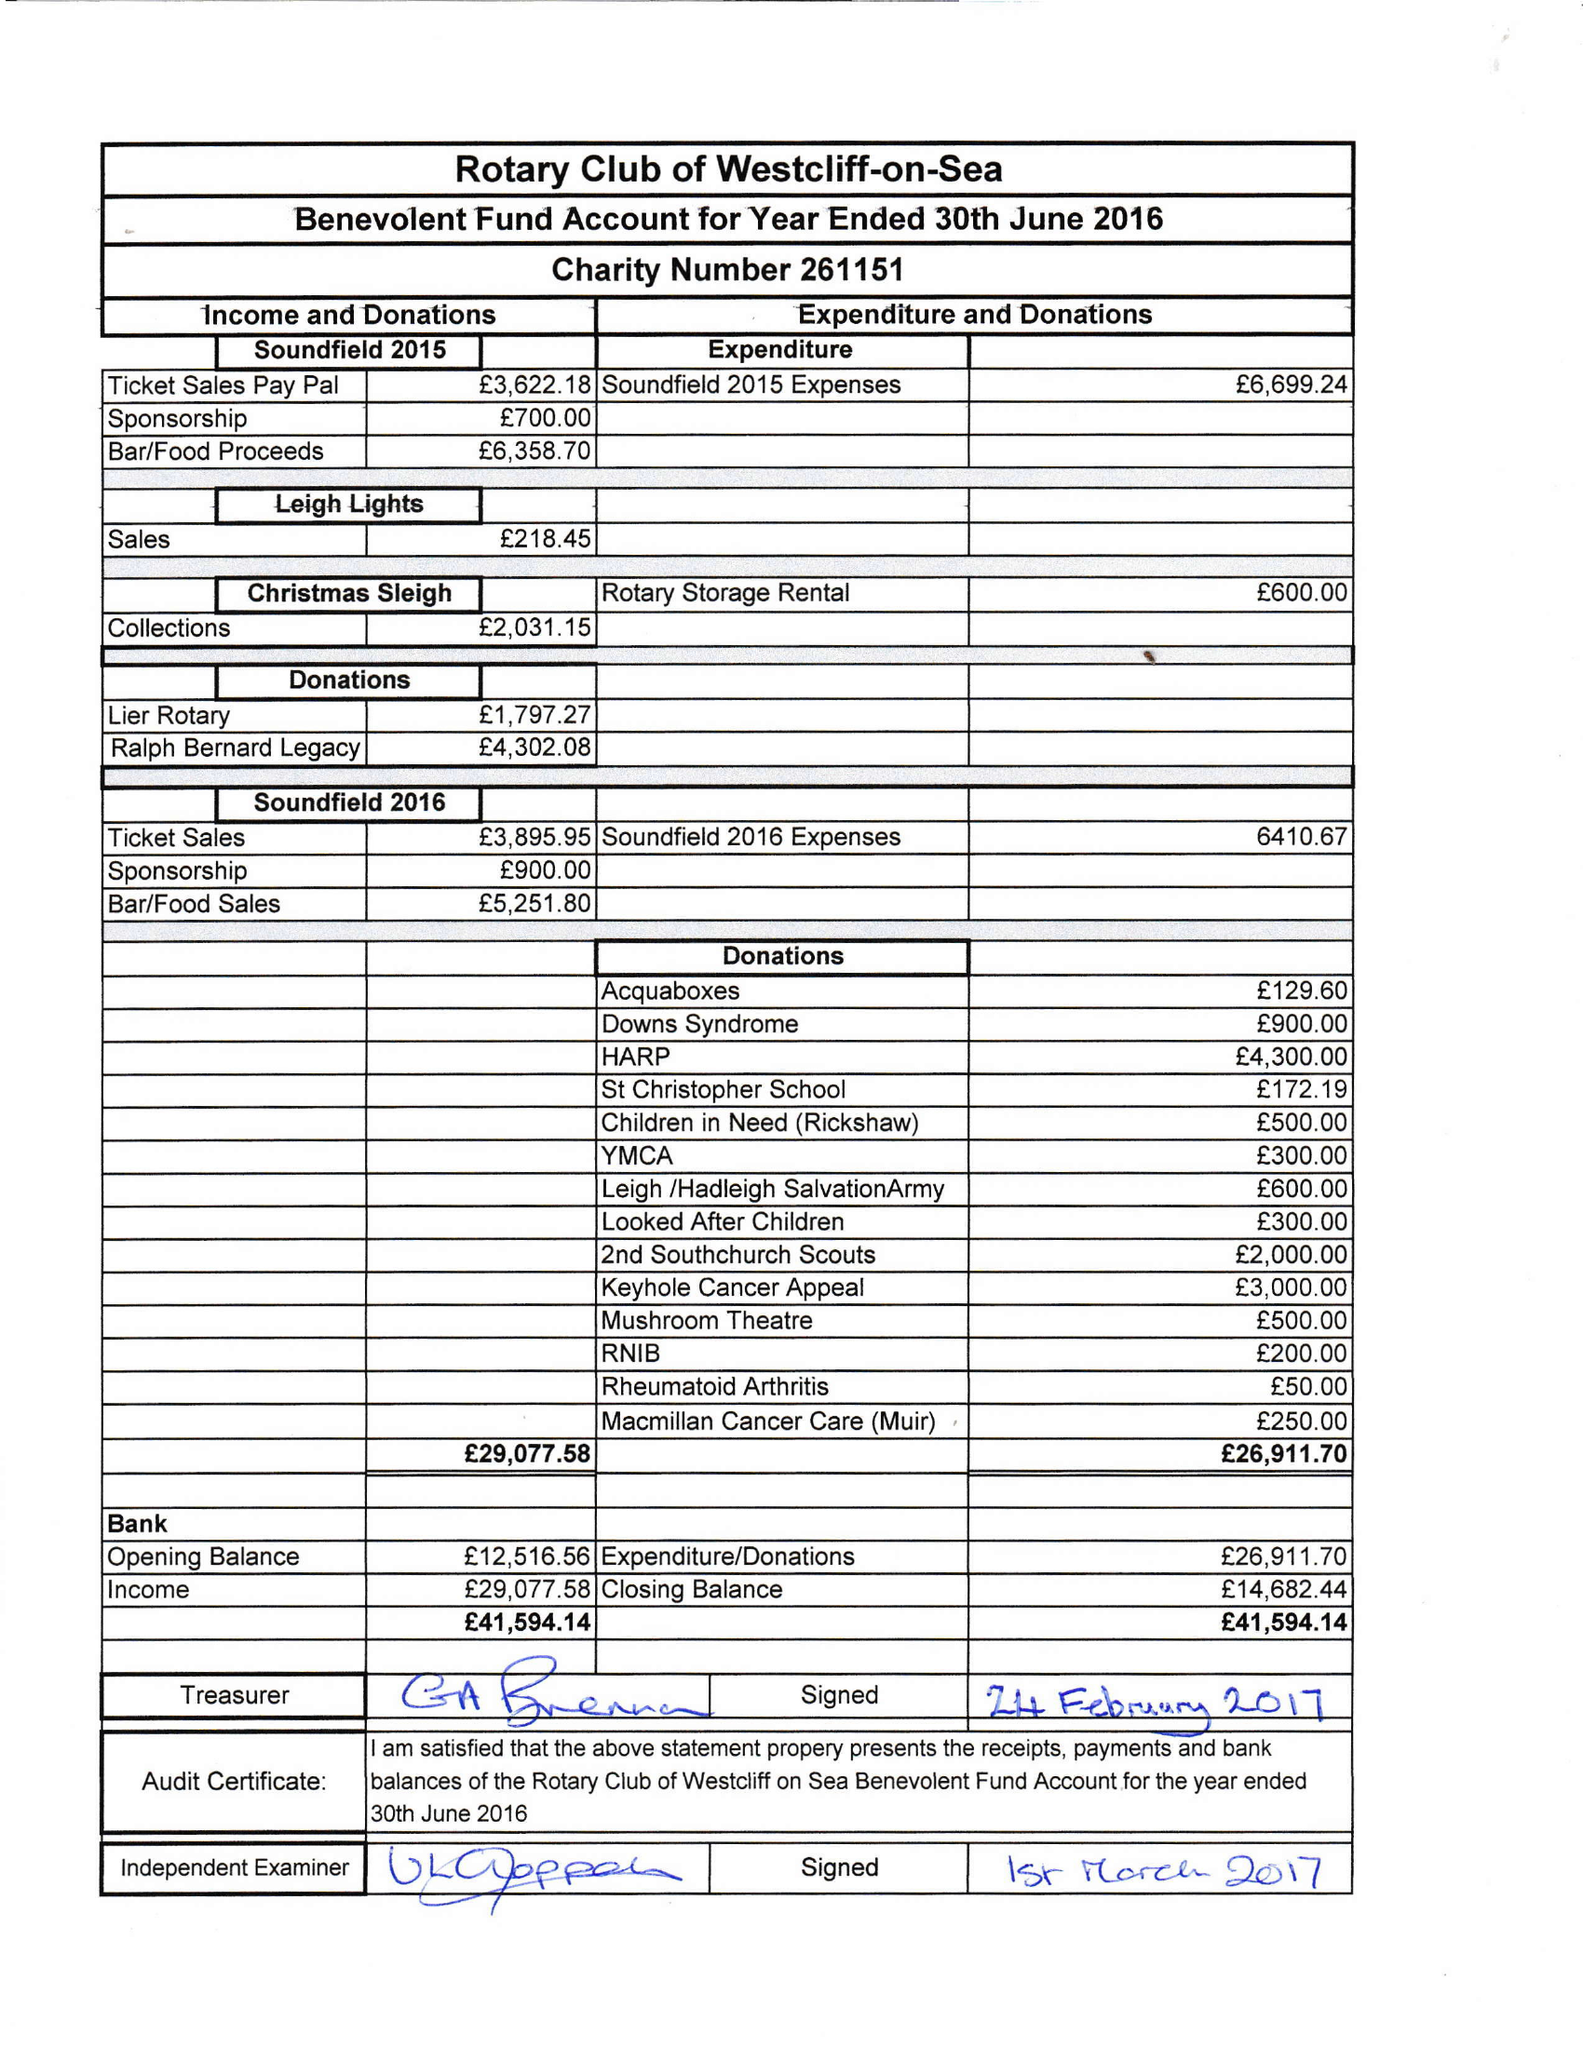What is the value for the charity_number?
Answer the question using a single word or phrase. 261151 